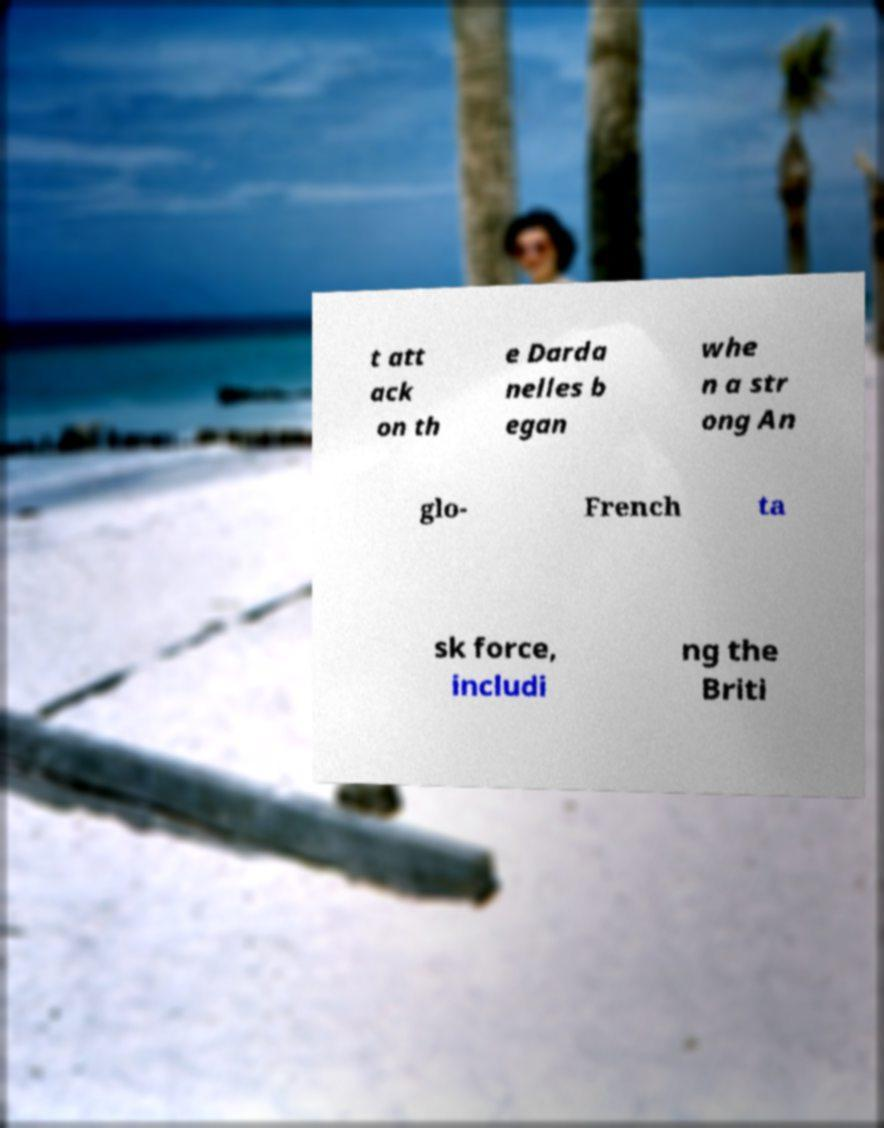Can you read and provide the text displayed in the image?This photo seems to have some interesting text. Can you extract and type it out for me? t att ack on th e Darda nelles b egan whe n a str ong An glo- French ta sk force, includi ng the Briti 